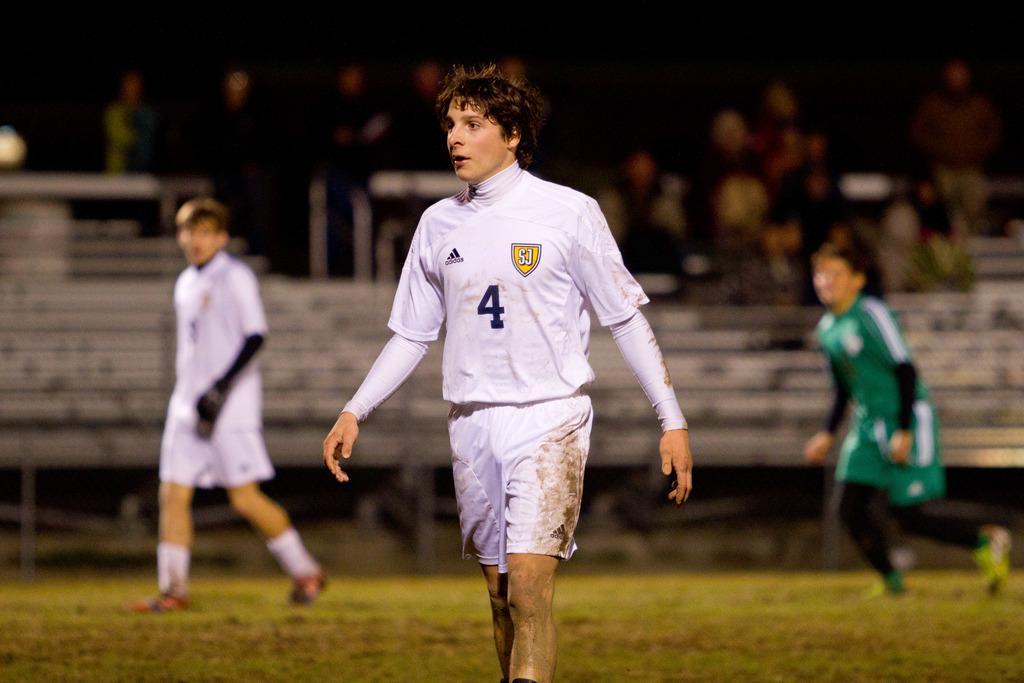Can you describe this image briefly? In this picture we can see two people walking on the grass. There is a person on the right side. Few people are visible in the background. 